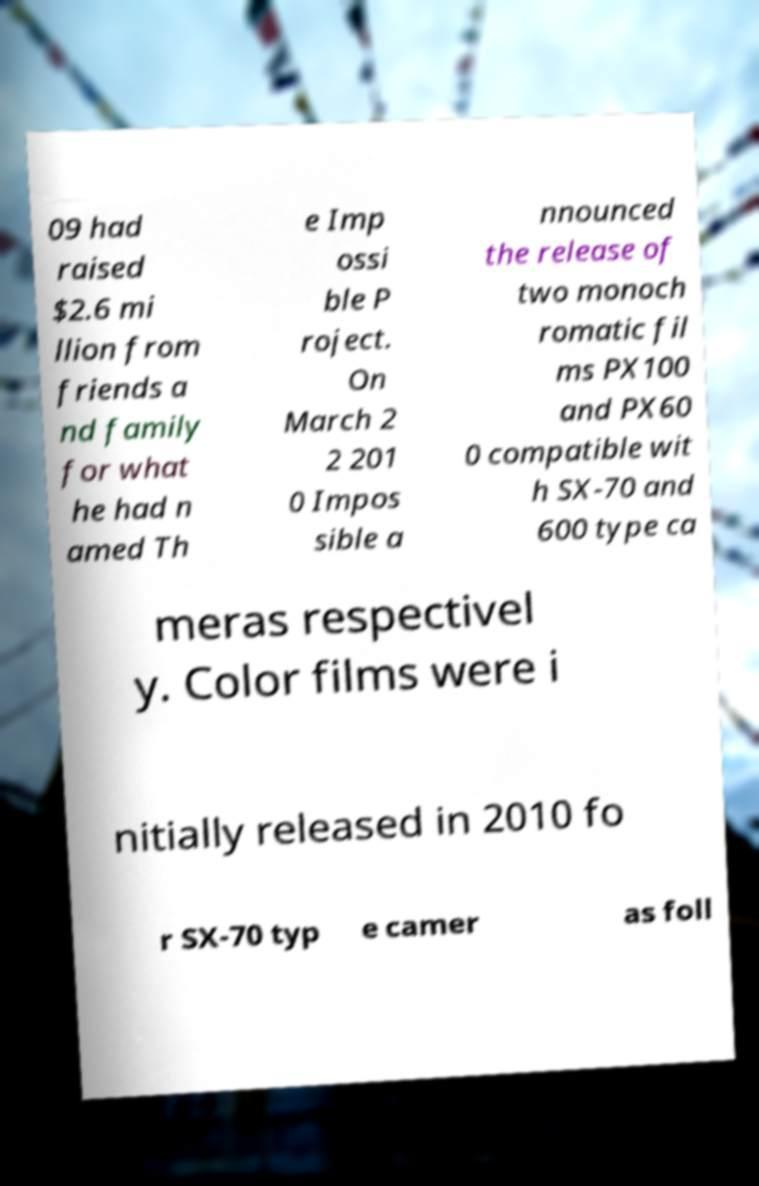Please read and relay the text visible in this image. What does it say? 09 had raised $2.6 mi llion from friends a nd family for what he had n amed Th e Imp ossi ble P roject. On March 2 2 201 0 Impos sible a nnounced the release of two monoch romatic fil ms PX100 and PX60 0 compatible wit h SX-70 and 600 type ca meras respectivel y. Color films were i nitially released in 2010 fo r SX-70 typ e camer as foll 